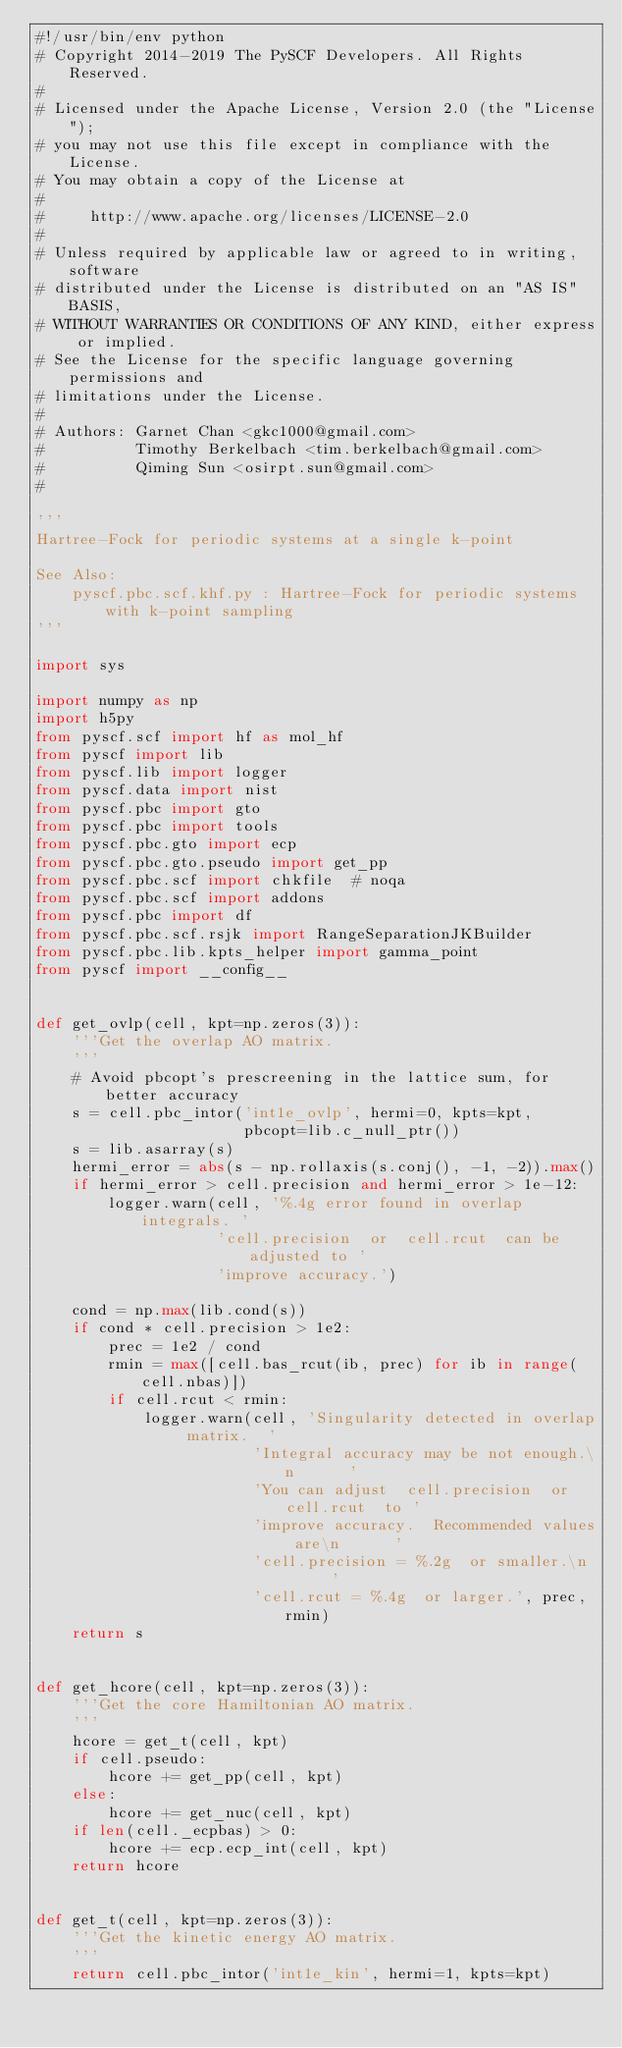Convert code to text. <code><loc_0><loc_0><loc_500><loc_500><_Python_>#!/usr/bin/env python
# Copyright 2014-2019 The PySCF Developers. All Rights Reserved.
#
# Licensed under the Apache License, Version 2.0 (the "License");
# you may not use this file except in compliance with the License.
# You may obtain a copy of the License at
#
#     http://www.apache.org/licenses/LICENSE-2.0
#
# Unless required by applicable law or agreed to in writing, software
# distributed under the License is distributed on an "AS IS" BASIS,
# WITHOUT WARRANTIES OR CONDITIONS OF ANY KIND, either express or implied.
# See the License for the specific language governing permissions and
# limitations under the License.
#
# Authors: Garnet Chan <gkc1000@gmail.com>
#          Timothy Berkelbach <tim.berkelbach@gmail.com>
#          Qiming Sun <osirpt.sun@gmail.com>
#

'''
Hartree-Fock for periodic systems at a single k-point

See Also:
    pyscf.pbc.scf.khf.py : Hartree-Fock for periodic systems with k-point sampling
'''

import sys

import numpy as np
import h5py
from pyscf.scf import hf as mol_hf
from pyscf import lib
from pyscf.lib import logger
from pyscf.data import nist
from pyscf.pbc import gto
from pyscf.pbc import tools
from pyscf.pbc.gto import ecp
from pyscf.pbc.gto.pseudo import get_pp
from pyscf.pbc.scf import chkfile  # noqa
from pyscf.pbc.scf import addons
from pyscf.pbc import df
from pyscf.pbc.scf.rsjk import RangeSeparationJKBuilder
from pyscf.pbc.lib.kpts_helper import gamma_point
from pyscf import __config__


def get_ovlp(cell, kpt=np.zeros(3)):
    '''Get the overlap AO matrix.
    '''
    # Avoid pbcopt's prescreening in the lattice sum, for better accuracy
    s = cell.pbc_intor('int1e_ovlp', hermi=0, kpts=kpt,
                       pbcopt=lib.c_null_ptr())
    s = lib.asarray(s)
    hermi_error = abs(s - np.rollaxis(s.conj(), -1, -2)).max()
    if hermi_error > cell.precision and hermi_error > 1e-12:
        logger.warn(cell, '%.4g error found in overlap integrals. '
                    'cell.precision  or  cell.rcut  can be adjusted to '
                    'improve accuracy.')

    cond = np.max(lib.cond(s))
    if cond * cell.precision > 1e2:
        prec = 1e2 / cond
        rmin = max([cell.bas_rcut(ib, prec) for ib in range(cell.nbas)])
        if cell.rcut < rmin:
            logger.warn(cell, 'Singularity detected in overlap matrix.  '
                        'Integral accuracy may be not enough.\n      '
                        'You can adjust  cell.precision  or  cell.rcut  to '
                        'improve accuracy.  Recommended values are\n      '
                        'cell.precision = %.2g  or smaller.\n      '
                        'cell.rcut = %.4g  or larger.', prec, rmin)
    return s


def get_hcore(cell, kpt=np.zeros(3)):
    '''Get the core Hamiltonian AO matrix.
    '''
    hcore = get_t(cell, kpt)
    if cell.pseudo:
        hcore += get_pp(cell, kpt)
    else:
        hcore += get_nuc(cell, kpt)
    if len(cell._ecpbas) > 0:
        hcore += ecp.ecp_int(cell, kpt)
    return hcore


def get_t(cell, kpt=np.zeros(3)):
    '''Get the kinetic energy AO matrix.
    '''
    return cell.pbc_intor('int1e_kin', hermi=1, kpts=kpt)

</code> 